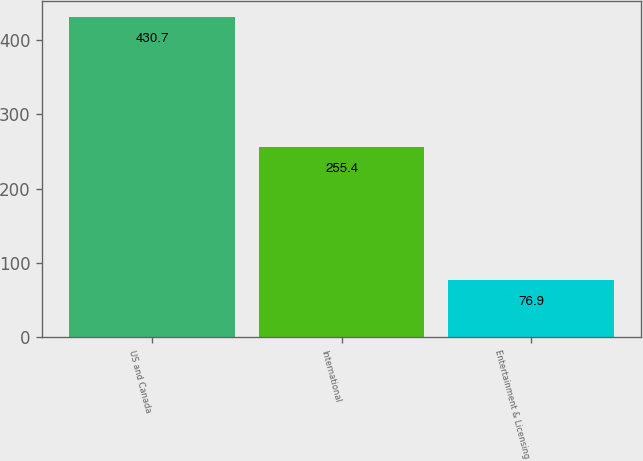Convert chart. <chart><loc_0><loc_0><loc_500><loc_500><bar_chart><fcel>US and Canada<fcel>International<fcel>Entertainment & Licensing<nl><fcel>430.7<fcel>255.4<fcel>76.9<nl></chart> 